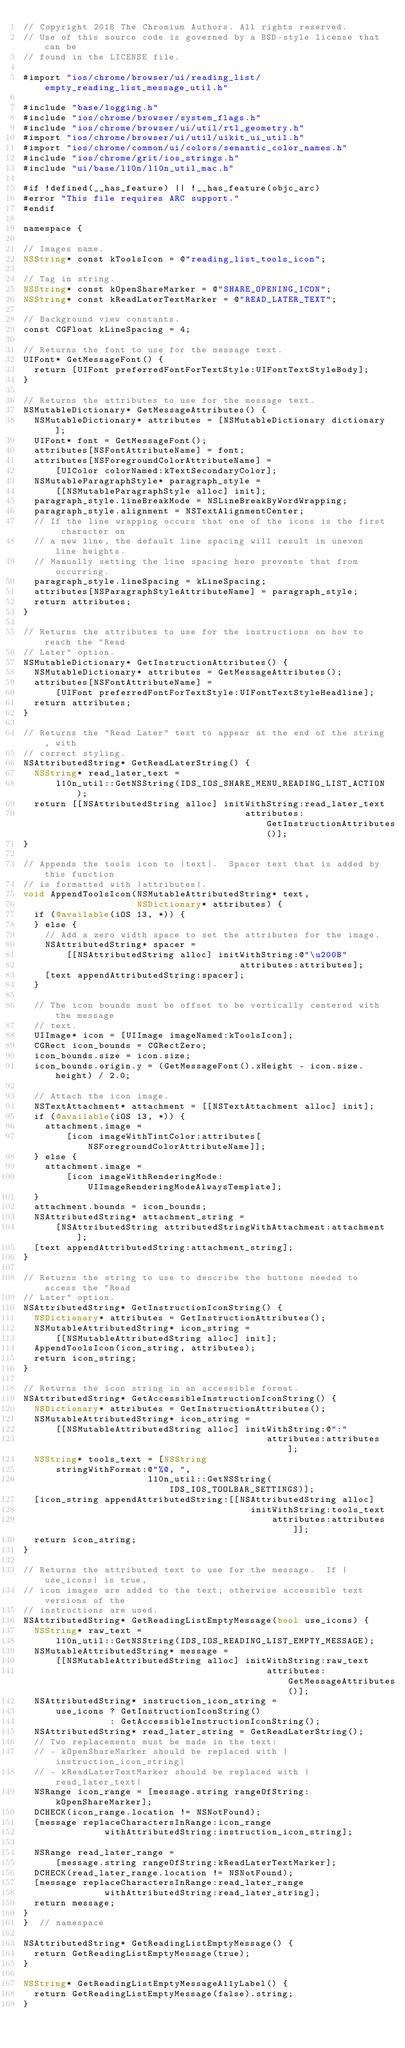Convert code to text. <code><loc_0><loc_0><loc_500><loc_500><_ObjectiveC_>// Copyright 2018 The Chromium Authors. All rights reserved.
// Use of this source code is governed by a BSD-style license that can be
// found in the LICENSE file.

#import "ios/chrome/browser/ui/reading_list/empty_reading_list_message_util.h"

#include "base/logging.h"
#include "ios/chrome/browser/system_flags.h"
#include "ios/chrome/browser/ui/util/rtl_geometry.h"
#import "ios/chrome/browser/ui/util/uikit_ui_util.h"
#import "ios/chrome/common/ui/colors/semantic_color_names.h"
#include "ios/chrome/grit/ios_strings.h"
#include "ui/base/l10n/l10n_util_mac.h"

#if !defined(__has_feature) || !__has_feature(objc_arc)
#error "This file requires ARC support."
#endif

namespace {

// Images name.
NSString* const kToolsIcon = @"reading_list_tools_icon";

// Tag in string.
NSString* const kOpenShareMarker = @"SHARE_OPENING_ICON";
NSString* const kReadLaterTextMarker = @"READ_LATER_TEXT";

// Background view constants.
const CGFloat kLineSpacing = 4;

// Returns the font to use for the message text.
UIFont* GetMessageFont() {
  return [UIFont preferredFontForTextStyle:UIFontTextStyleBody];
}

// Returns the attributes to use for the message text.
NSMutableDictionary* GetMessageAttributes() {
  NSMutableDictionary* attributes = [NSMutableDictionary dictionary];
  UIFont* font = GetMessageFont();
  attributes[NSFontAttributeName] = font;
  attributes[NSForegroundColorAttributeName] =
      [UIColor colorNamed:kTextSecondaryColor];
  NSMutableParagraphStyle* paragraph_style =
      [[NSMutableParagraphStyle alloc] init];
  paragraph_style.lineBreakMode = NSLineBreakByWordWrapping;
  paragraph_style.alignment = NSTextAlignmentCenter;
  // If the line wrapping occurs that one of the icons is the first character on
  // a new line, the default line spacing will result in uneven line heights.
  // Manually setting the line spacing here prevents that from occurring.
  paragraph_style.lineSpacing = kLineSpacing;
  attributes[NSParagraphStyleAttributeName] = paragraph_style;
  return attributes;
}

// Returns the attributes to use for the instructions on how to reach the "Read
// Later" option.
NSMutableDictionary* GetInstructionAttributes() {
  NSMutableDictionary* attributes = GetMessageAttributes();
  attributes[NSFontAttributeName] =
      [UIFont preferredFontForTextStyle:UIFontTextStyleHeadline];
  return attributes;
}

// Returns the "Read Later" text to appear at the end of the string, with
// correct styling.
NSAttributedString* GetReadLaterString() {
  NSString* read_later_text =
      l10n_util::GetNSString(IDS_IOS_SHARE_MENU_READING_LIST_ACTION);
  return [[NSAttributedString alloc] initWithString:read_later_text
                                         attributes:GetInstructionAttributes()];
}

// Appends the tools icon to |text|.  Spacer text that is added by this function
// is formatted with |attributes|.
void AppendToolsIcon(NSMutableAttributedString* text,
                     NSDictionary* attributes) {
  if (@available(iOS 13, *)) {
  } else {
    // Add a zero width space to set the attributes for the image.
    NSAttributedString* spacer =
        [[NSAttributedString alloc] initWithString:@"\u200B"
                                        attributes:attributes];
    [text appendAttributedString:spacer];
  }

  // The icon bounds must be offset to be vertically centered with the message
  // text.
  UIImage* icon = [UIImage imageNamed:kToolsIcon];
  CGRect icon_bounds = CGRectZero;
  icon_bounds.size = icon.size;
  icon_bounds.origin.y = (GetMessageFont().xHeight - icon.size.height) / 2.0;

  // Attach the icon image.
  NSTextAttachment* attachment = [[NSTextAttachment alloc] init];
  if (@available(iOS 13, *)) {
    attachment.image =
        [icon imageWithTintColor:attributes[NSForegroundColorAttributeName]];
  } else {
    attachment.image =
        [icon imageWithRenderingMode:UIImageRenderingModeAlwaysTemplate];
  }
  attachment.bounds = icon_bounds;
  NSAttributedString* attachment_string =
      [NSAttributedString attributedStringWithAttachment:attachment];
  [text appendAttributedString:attachment_string];
}

// Returns the string to use to describe the buttons needed to access the "Read
// Later" option.
NSAttributedString* GetInstructionIconString() {
  NSDictionary* attributes = GetInstructionAttributes();
  NSMutableAttributedString* icon_string =
      [[NSMutableAttributedString alloc] init];
  AppendToolsIcon(icon_string, attributes);
  return icon_string;
}

// Returns the icon string in an accessible format.
NSAttributedString* GetAccessibleInstructionIconString() {
  NSDictionary* attributes = GetInstructionAttributes();
  NSMutableAttributedString* icon_string =
      [[NSMutableAttributedString alloc] initWithString:@":"
                                             attributes:attributes];
  NSString* tools_text = [NSString
      stringWithFormat:@"%@, ",
                       l10n_util::GetNSString(IDS_IOS_TOOLBAR_SETTINGS)];
  [icon_string appendAttributedString:[[NSAttributedString alloc]
                                          initWithString:tools_text
                                              attributes:attributes]];
  return icon_string;
}

// Returns the attributed text to use for the message.  If |use_icons| is true,
// icon images are added to the text; otherwise accessible text versions of the
// instructions are used.
NSAttributedString* GetReadingListEmptyMessage(bool use_icons) {
  NSString* raw_text =
      l10n_util::GetNSString(IDS_IOS_READING_LIST_EMPTY_MESSAGE);
  NSMutableAttributedString* message =
      [[NSMutableAttributedString alloc] initWithString:raw_text
                                             attributes:GetMessageAttributes()];
  NSAttributedString* instruction_icon_string =
      use_icons ? GetInstructionIconString()
                : GetAccessibleInstructionIconString();
  NSAttributedString* read_later_string = GetReadLaterString();
  // Two replacements must be made in the text:
  // - kOpenShareMarker should be replaced with |instruction_icon_string|
  // - kReadLaterTextMarker should be replaced with |read_later_text|
  NSRange icon_range = [message.string rangeOfString:kOpenShareMarker];
  DCHECK(icon_range.location != NSNotFound);
  [message replaceCharactersInRange:icon_range
               withAttributedString:instruction_icon_string];

  NSRange read_later_range =
      [message.string rangeOfString:kReadLaterTextMarker];
  DCHECK(read_later_range.location != NSNotFound);
  [message replaceCharactersInRange:read_later_range
               withAttributedString:read_later_string];
  return message;
}
}  // namespace

NSAttributedString* GetReadingListEmptyMessage() {
  return GetReadingListEmptyMessage(true);
}

NSString* GetReadingListEmptyMessageA11yLabel() {
  return GetReadingListEmptyMessage(false).string;
}
</code> 